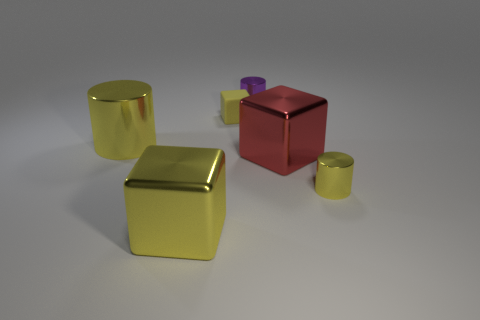Add 3 shiny cylinders. How many objects exist? 9 Add 6 red metallic objects. How many red metallic objects exist? 7 Subtract 0 yellow balls. How many objects are left? 6 Subtract all purple metallic cylinders. Subtract all small yellow rubber objects. How many objects are left? 4 Add 3 yellow cubes. How many yellow cubes are left? 5 